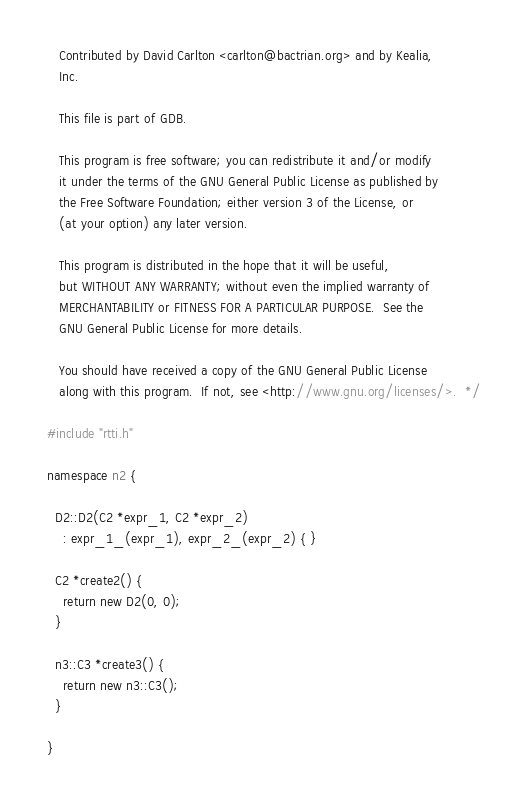Convert code to text. <code><loc_0><loc_0><loc_500><loc_500><_C++_>
   Contributed by David Carlton <carlton@bactrian.org> and by Kealia,
   Inc.

   This file is part of GDB.

   This program is free software; you can redistribute it and/or modify
   it under the terms of the GNU General Public License as published by
   the Free Software Foundation; either version 3 of the License, or
   (at your option) any later version.

   This program is distributed in the hope that it will be useful,
   but WITHOUT ANY WARRANTY; without even the implied warranty of
   MERCHANTABILITY or FITNESS FOR A PARTICULAR PURPOSE.  See the
   GNU General Public License for more details.

   You should have received a copy of the GNU General Public License
   along with this program.  If not, see <http://www.gnu.org/licenses/>.  */

#include "rtti.h"

namespace n2 {
  
  D2::D2(C2 *expr_1, C2 *expr_2)
    : expr_1_(expr_1), expr_2_(expr_2) { }

  C2 *create2() {
    return new D2(0, 0);
  }

  n3::C3 *create3() {
    return new n3::C3();
  }

}
</code> 